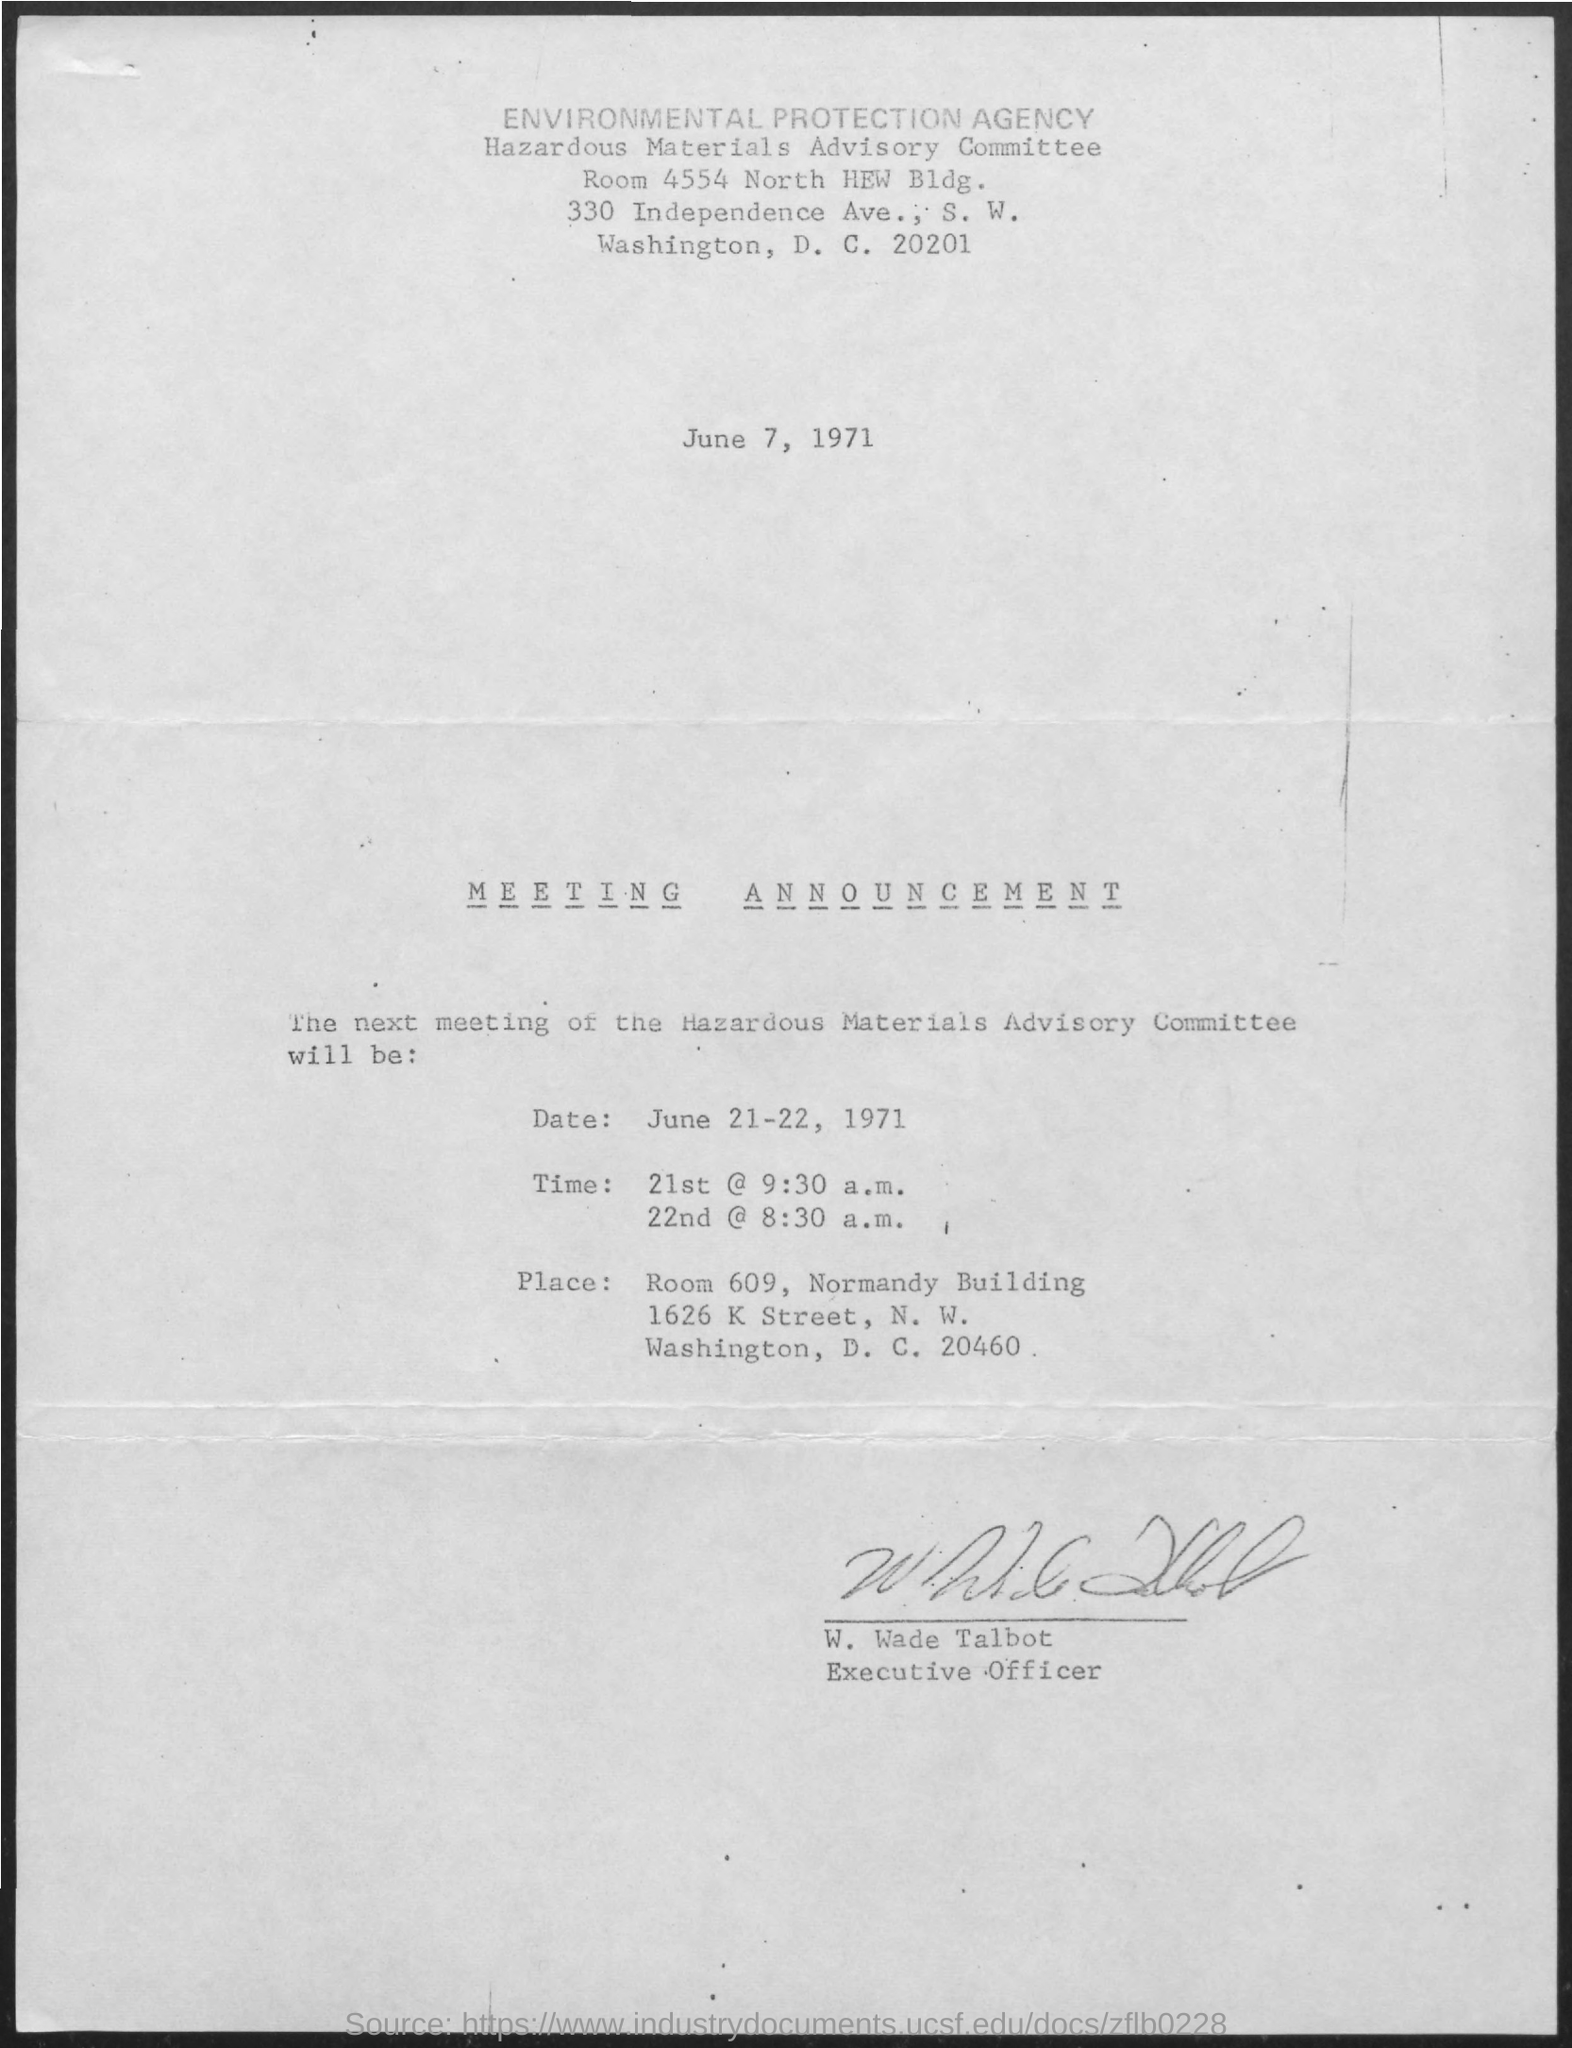Highlight a few significant elements in this photo. W. Wade Talbot holds the designation of Executive Officer. On June 21st, 1971, the Hazardous Materials Advisory Committee meeting was announced to take place at 9:30 a.m. The Hazardous Materials Advisory Committee meeting will take place on June 21-22, 1971. The Hazardous Materials Advisory Committee meeting was announced on June 22nd, 1971 at 8:30 a.m. The document has been signed by W. Wade Talbot. 